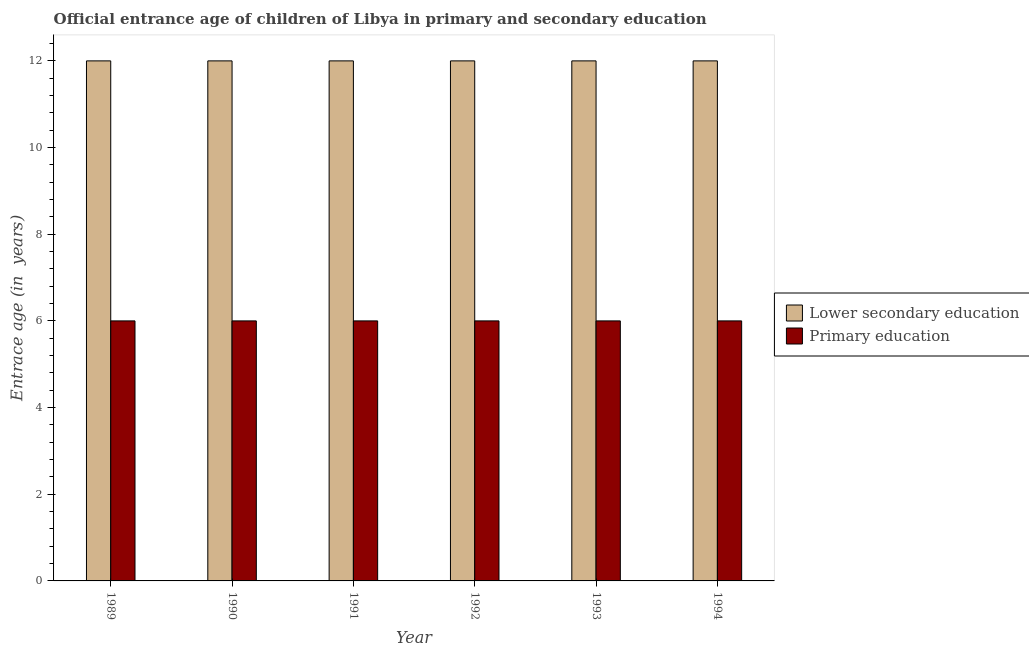Are the number of bars on each tick of the X-axis equal?
Your answer should be compact. Yes. What is the label of the 6th group of bars from the left?
Make the answer very short. 1994. In how many cases, is the number of bars for a given year not equal to the number of legend labels?
Offer a very short reply. 0. Across all years, what is the maximum entrance age of children in lower secondary education?
Your answer should be very brief. 12. In which year was the entrance age of children in lower secondary education maximum?
Offer a very short reply. 1989. What is the total entrance age of chiildren in primary education in the graph?
Make the answer very short. 36. What is the difference between the entrance age of children in lower secondary education in 1989 and that in 1990?
Your answer should be compact. 0. In the year 1994, what is the difference between the entrance age of children in lower secondary education and entrance age of chiildren in primary education?
Keep it short and to the point. 0. In how many years, is the entrance age of children in lower secondary education greater than 2.4 years?
Give a very brief answer. 6. Is the entrance age of children in lower secondary education in 1990 less than that in 1994?
Give a very brief answer. No. Is the difference between the entrance age of chiildren in primary education in 1990 and 1993 greater than the difference between the entrance age of children in lower secondary education in 1990 and 1993?
Offer a very short reply. No. What is the difference between the highest and the second highest entrance age of chiildren in primary education?
Offer a very short reply. 0. Is the sum of the entrance age of children in lower secondary education in 1990 and 1993 greater than the maximum entrance age of chiildren in primary education across all years?
Offer a very short reply. Yes. What does the 1st bar from the left in 1989 represents?
Give a very brief answer. Lower secondary education. What does the 2nd bar from the right in 1992 represents?
Give a very brief answer. Lower secondary education. How many bars are there?
Ensure brevity in your answer.  12. Are all the bars in the graph horizontal?
Offer a terse response. No. What is the difference between two consecutive major ticks on the Y-axis?
Make the answer very short. 2. Are the values on the major ticks of Y-axis written in scientific E-notation?
Your response must be concise. No. Does the graph contain any zero values?
Provide a succinct answer. No. How many legend labels are there?
Your answer should be compact. 2. How are the legend labels stacked?
Offer a very short reply. Vertical. What is the title of the graph?
Provide a short and direct response. Official entrance age of children of Libya in primary and secondary education. Does "Under-5(male)" appear as one of the legend labels in the graph?
Offer a terse response. No. What is the label or title of the Y-axis?
Offer a terse response. Entrace age (in  years). What is the Entrace age (in  years) of Lower secondary education in 1991?
Offer a very short reply. 12. What is the Entrace age (in  years) of Primary education in 1991?
Offer a very short reply. 6. What is the Entrace age (in  years) of Lower secondary education in 1993?
Give a very brief answer. 12. What is the Entrace age (in  years) of Primary education in 1993?
Your answer should be compact. 6. What is the Entrace age (in  years) in Primary education in 1994?
Provide a short and direct response. 6. Across all years, what is the maximum Entrace age (in  years) of Lower secondary education?
Make the answer very short. 12. Across all years, what is the maximum Entrace age (in  years) in Primary education?
Your answer should be compact. 6. Across all years, what is the minimum Entrace age (in  years) of Lower secondary education?
Make the answer very short. 12. Across all years, what is the minimum Entrace age (in  years) of Primary education?
Your answer should be compact. 6. What is the total Entrace age (in  years) of Lower secondary education in the graph?
Your answer should be very brief. 72. What is the difference between the Entrace age (in  years) of Lower secondary education in 1989 and that in 1991?
Provide a succinct answer. 0. What is the difference between the Entrace age (in  years) in Primary education in 1989 and that in 1991?
Offer a very short reply. 0. What is the difference between the Entrace age (in  years) of Lower secondary education in 1989 and that in 1992?
Keep it short and to the point. 0. What is the difference between the Entrace age (in  years) of Primary education in 1989 and that in 1994?
Give a very brief answer. 0. What is the difference between the Entrace age (in  years) in Lower secondary education in 1990 and that in 1991?
Your answer should be compact. 0. What is the difference between the Entrace age (in  years) in Primary education in 1990 and that in 1991?
Provide a succinct answer. 0. What is the difference between the Entrace age (in  years) of Primary education in 1990 and that in 1992?
Provide a succinct answer. 0. What is the difference between the Entrace age (in  years) in Lower secondary education in 1990 and that in 1994?
Your answer should be very brief. 0. What is the difference between the Entrace age (in  years) in Lower secondary education in 1991 and that in 1992?
Provide a succinct answer. 0. What is the difference between the Entrace age (in  years) in Primary education in 1991 and that in 1992?
Your answer should be compact. 0. What is the difference between the Entrace age (in  years) in Lower secondary education in 1991 and that in 1993?
Your answer should be very brief. 0. What is the difference between the Entrace age (in  years) in Primary education in 1991 and that in 1993?
Keep it short and to the point. 0. What is the difference between the Entrace age (in  years) in Lower secondary education in 1991 and that in 1994?
Give a very brief answer. 0. What is the difference between the Entrace age (in  years) in Primary education in 1992 and that in 1993?
Give a very brief answer. 0. What is the difference between the Entrace age (in  years) in Lower secondary education in 1993 and that in 1994?
Keep it short and to the point. 0. What is the difference between the Entrace age (in  years) of Primary education in 1993 and that in 1994?
Your response must be concise. 0. What is the difference between the Entrace age (in  years) of Lower secondary education in 1989 and the Entrace age (in  years) of Primary education in 1991?
Make the answer very short. 6. What is the difference between the Entrace age (in  years) of Lower secondary education in 1989 and the Entrace age (in  years) of Primary education in 1994?
Keep it short and to the point. 6. What is the difference between the Entrace age (in  years) of Lower secondary education in 1990 and the Entrace age (in  years) of Primary education in 1993?
Ensure brevity in your answer.  6. What is the difference between the Entrace age (in  years) in Lower secondary education in 1991 and the Entrace age (in  years) in Primary education in 1993?
Make the answer very short. 6. What is the difference between the Entrace age (in  years) of Lower secondary education in 1991 and the Entrace age (in  years) of Primary education in 1994?
Provide a succinct answer. 6. What is the difference between the Entrace age (in  years) of Lower secondary education in 1992 and the Entrace age (in  years) of Primary education in 1993?
Make the answer very short. 6. What is the average Entrace age (in  years) in Lower secondary education per year?
Ensure brevity in your answer.  12. In the year 1990, what is the difference between the Entrace age (in  years) in Lower secondary education and Entrace age (in  years) in Primary education?
Offer a very short reply. 6. In the year 1992, what is the difference between the Entrace age (in  years) of Lower secondary education and Entrace age (in  years) of Primary education?
Provide a succinct answer. 6. In the year 1993, what is the difference between the Entrace age (in  years) of Lower secondary education and Entrace age (in  years) of Primary education?
Your answer should be compact. 6. What is the ratio of the Entrace age (in  years) in Primary education in 1989 to that in 1990?
Offer a terse response. 1. What is the ratio of the Entrace age (in  years) in Primary education in 1989 to that in 1991?
Provide a short and direct response. 1. What is the ratio of the Entrace age (in  years) of Lower secondary education in 1989 to that in 1992?
Offer a very short reply. 1. What is the ratio of the Entrace age (in  years) of Primary education in 1989 to that in 1992?
Your answer should be very brief. 1. What is the ratio of the Entrace age (in  years) of Lower secondary education in 1989 to that in 1993?
Keep it short and to the point. 1. What is the ratio of the Entrace age (in  years) in Primary education in 1989 to that in 1993?
Ensure brevity in your answer.  1. What is the ratio of the Entrace age (in  years) in Lower secondary education in 1990 to that in 1991?
Provide a succinct answer. 1. What is the ratio of the Entrace age (in  years) of Primary education in 1990 to that in 1991?
Your response must be concise. 1. What is the ratio of the Entrace age (in  years) in Lower secondary education in 1990 to that in 1992?
Keep it short and to the point. 1. What is the ratio of the Entrace age (in  years) in Primary education in 1990 to that in 1992?
Ensure brevity in your answer.  1. What is the ratio of the Entrace age (in  years) in Lower secondary education in 1990 to that in 1994?
Provide a short and direct response. 1. What is the ratio of the Entrace age (in  years) in Primary education in 1990 to that in 1994?
Ensure brevity in your answer.  1. What is the ratio of the Entrace age (in  years) in Primary education in 1991 to that in 1992?
Offer a very short reply. 1. What is the ratio of the Entrace age (in  years) in Lower secondary education in 1991 to that in 1993?
Make the answer very short. 1. What is the ratio of the Entrace age (in  years) in Lower secondary education in 1991 to that in 1994?
Your response must be concise. 1. What is the ratio of the Entrace age (in  years) in Primary education in 1992 to that in 1993?
Your answer should be compact. 1. What is the ratio of the Entrace age (in  years) in Primary education in 1993 to that in 1994?
Keep it short and to the point. 1. What is the difference between the highest and the second highest Entrace age (in  years) in Lower secondary education?
Your answer should be compact. 0. What is the difference between the highest and the second highest Entrace age (in  years) in Primary education?
Ensure brevity in your answer.  0. 